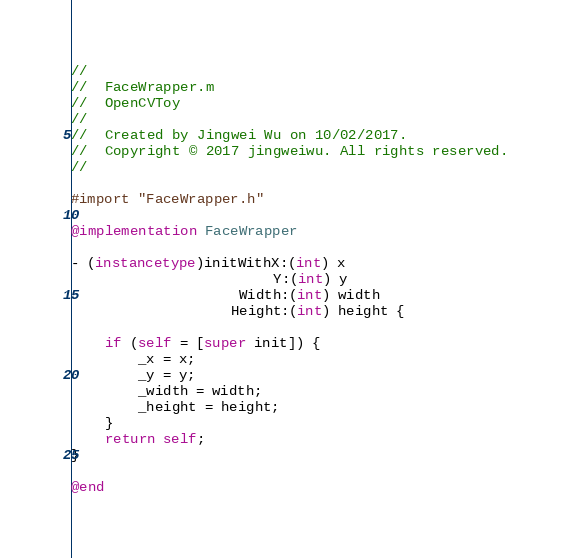<code> <loc_0><loc_0><loc_500><loc_500><_ObjectiveC_>//
//  FaceWrapper.m
//  OpenCVToy
//
//  Created by Jingwei Wu on 10/02/2017.
//  Copyright © 2017 jingweiwu. All rights reserved.
//

#import "FaceWrapper.h"

@implementation FaceWrapper

- (instancetype)initWithX:(int) x
                        Y:(int) y
                    Width:(int) width
                   Height:(int) height {
    
    if (self = [super init]) {
        _x = x;
        _y = y;
        _width = width;
        _height = height;
    }
    return self;
}

@end
</code> 